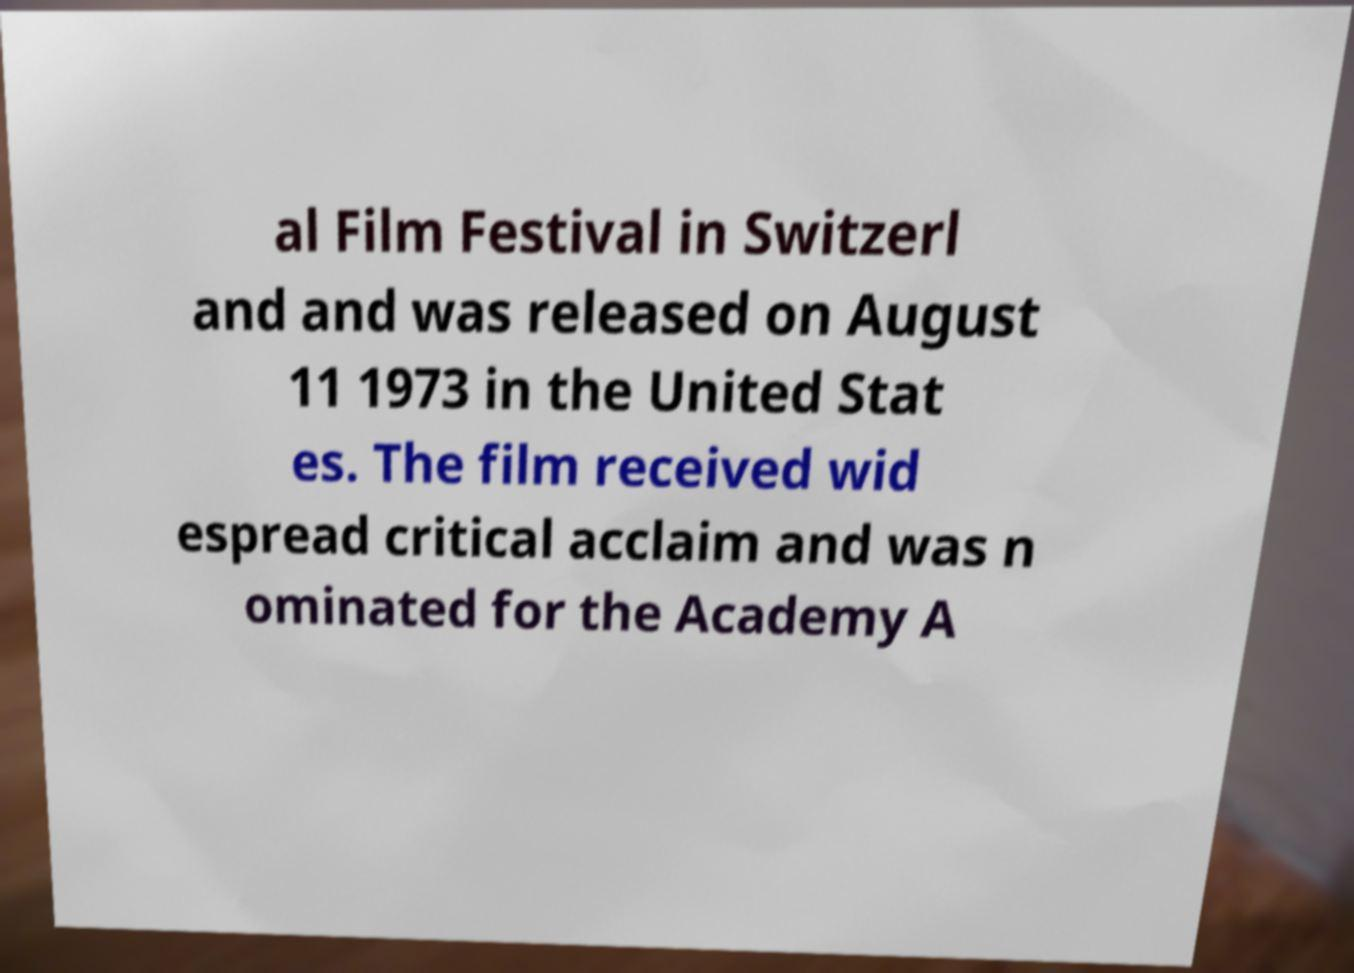I need the written content from this picture converted into text. Can you do that? al Film Festival in Switzerl and and was released on August 11 1973 in the United Stat es. The film received wid espread critical acclaim and was n ominated for the Academy A 